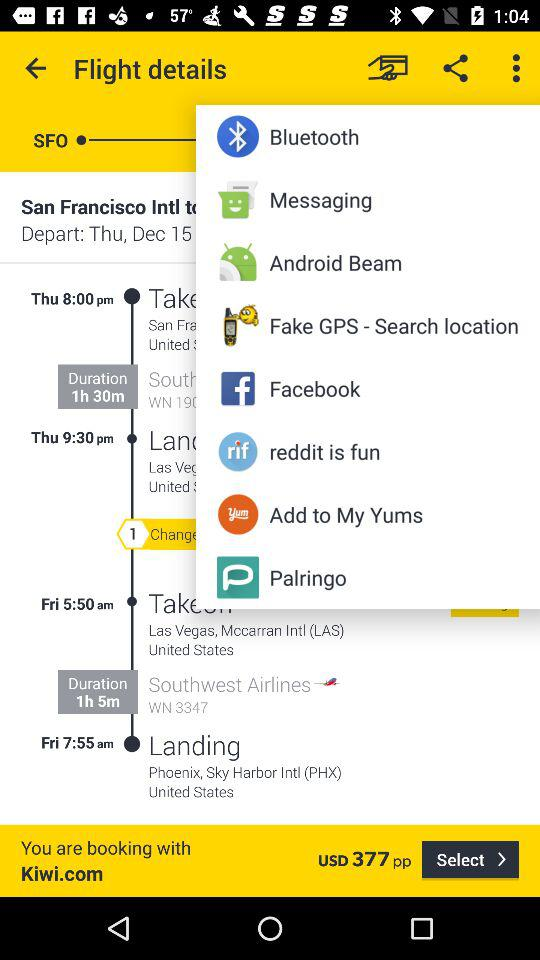How many notifications are there in "Messaging"?
When the provided information is insufficient, respond with <no answer>. <no answer> 